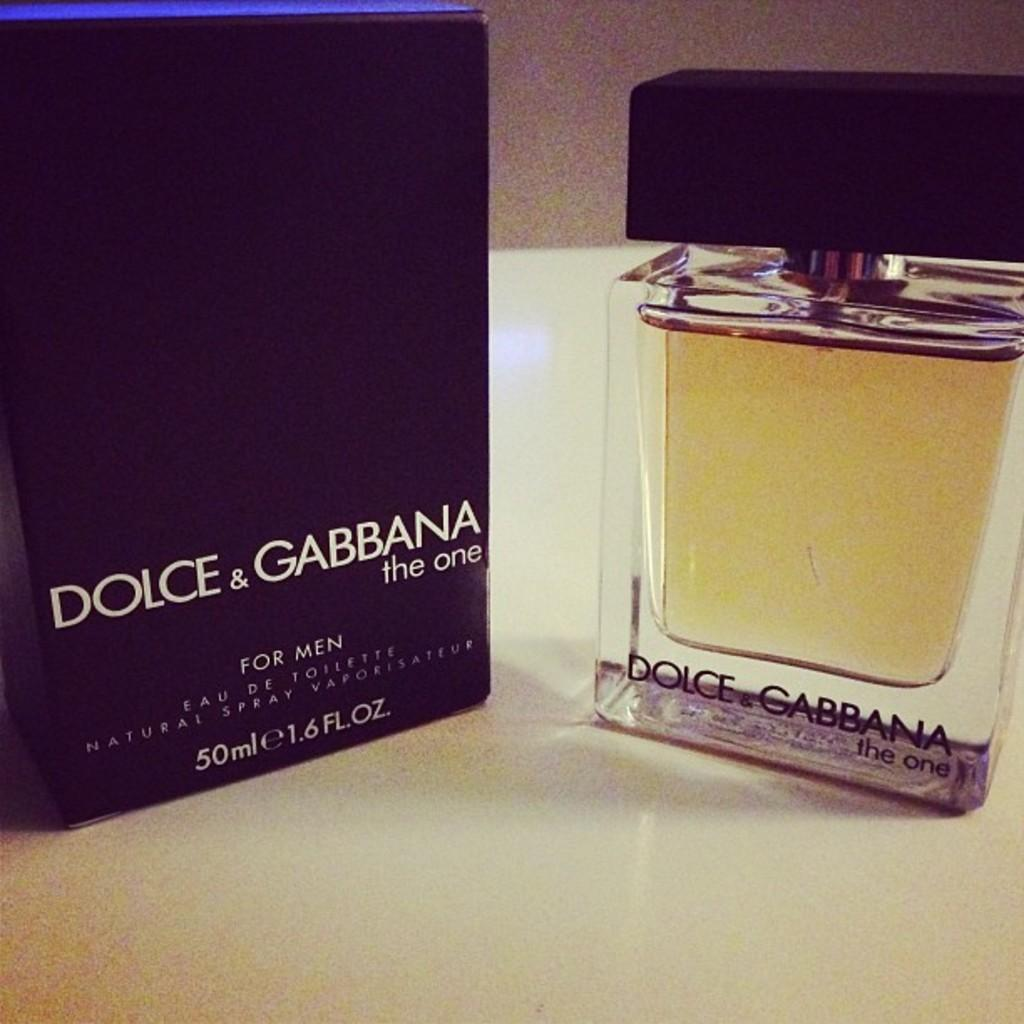<image>
Write a terse but informative summary of the picture. A black Dolce & Gabbana box next to a clear bottle of cologne. 